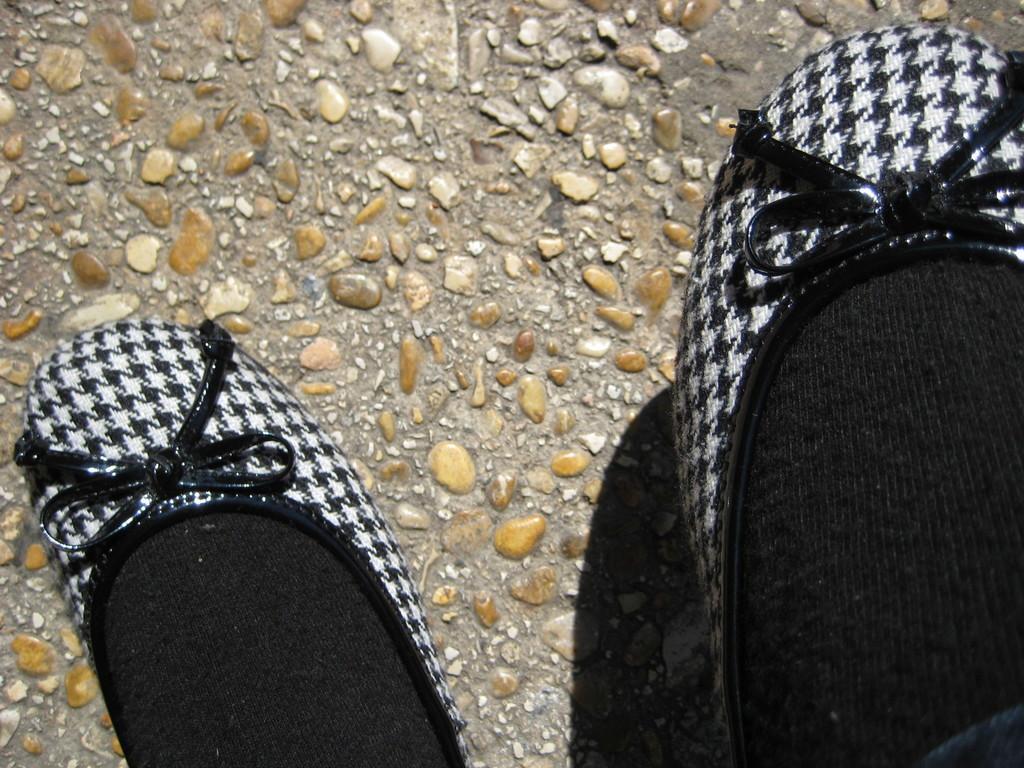In one or two sentences, can you explain what this image depicts? In this image we can see a person wearing shoes and socks. In the background there are stones. 